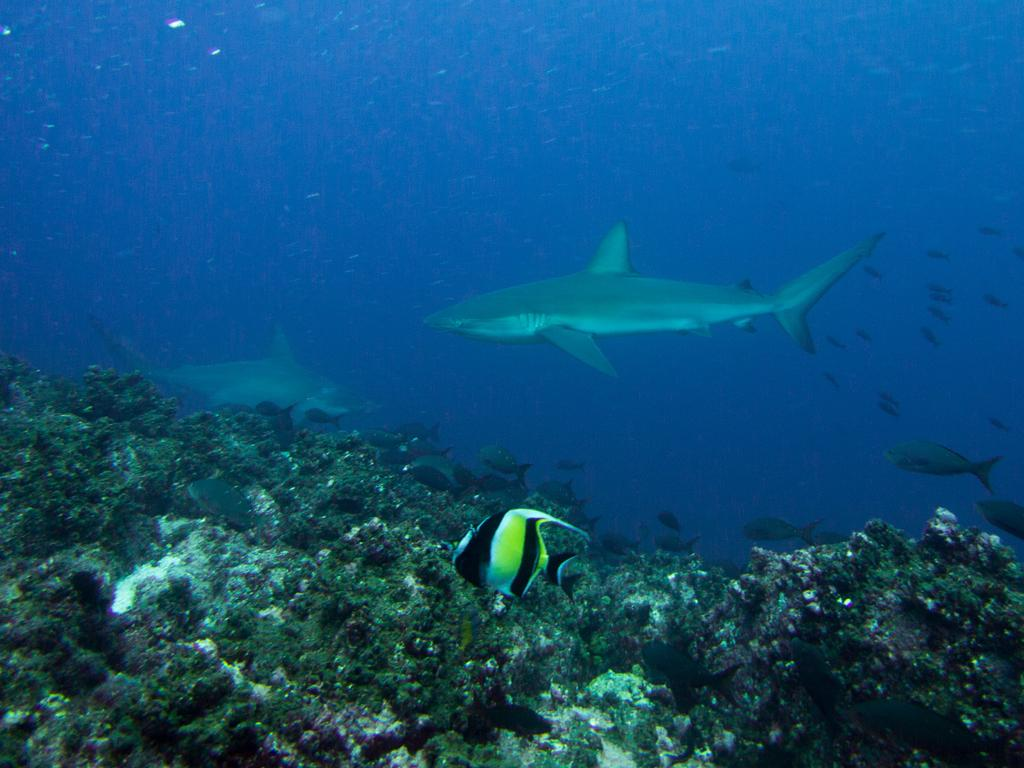Where was the image taken? The image is taken in the sea. What can be seen at the bottom of the image? There are many coral reefs at the bottom of the image. What else is present in the water in the middle of the image? There are a few fishes in the water in the middle of the image. What type of patch is visible in the fog in the image? There is no fog or patch present in the image; it is taken underwater in the sea. 